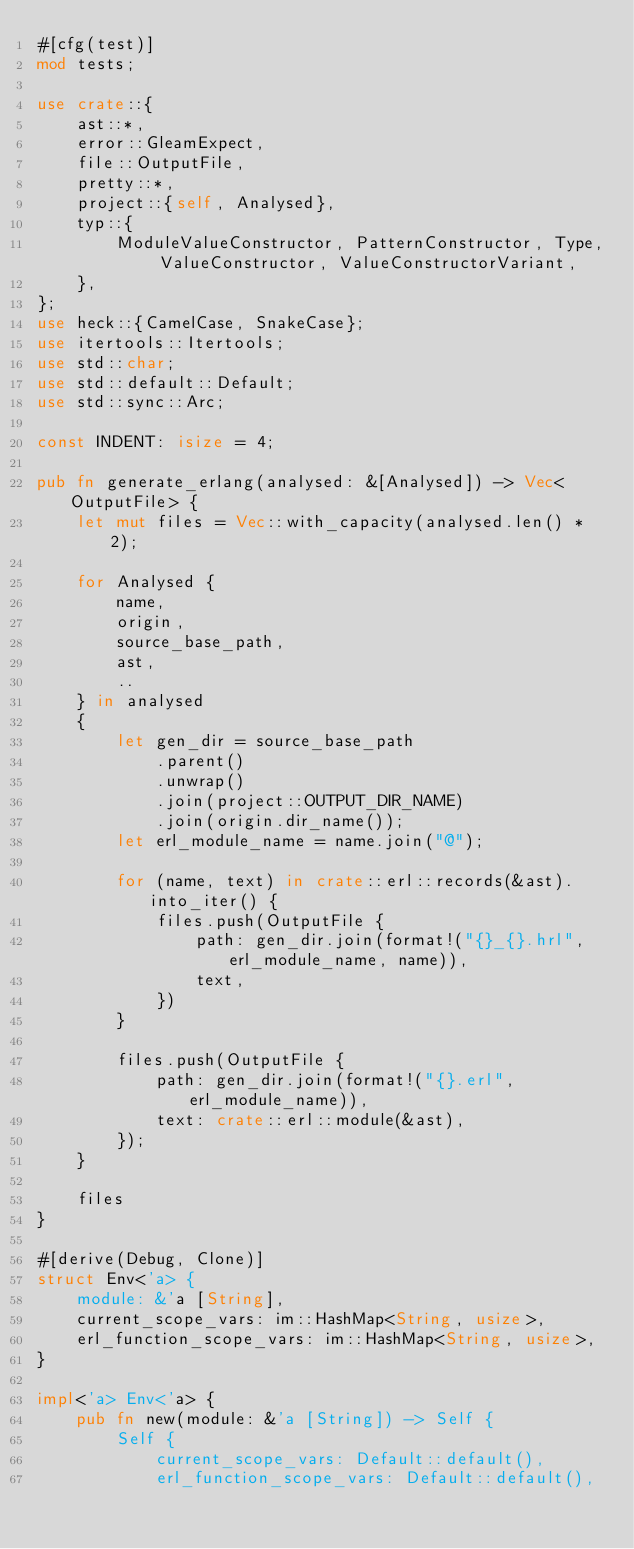Convert code to text. <code><loc_0><loc_0><loc_500><loc_500><_Rust_>#[cfg(test)]
mod tests;

use crate::{
    ast::*,
    error::GleamExpect,
    file::OutputFile,
    pretty::*,
    project::{self, Analysed},
    typ::{
        ModuleValueConstructor, PatternConstructor, Type, ValueConstructor, ValueConstructorVariant,
    },
};
use heck::{CamelCase, SnakeCase};
use itertools::Itertools;
use std::char;
use std::default::Default;
use std::sync::Arc;

const INDENT: isize = 4;

pub fn generate_erlang(analysed: &[Analysed]) -> Vec<OutputFile> {
    let mut files = Vec::with_capacity(analysed.len() * 2);

    for Analysed {
        name,
        origin,
        source_base_path,
        ast,
        ..
    } in analysed
    {
        let gen_dir = source_base_path
            .parent()
            .unwrap()
            .join(project::OUTPUT_DIR_NAME)
            .join(origin.dir_name());
        let erl_module_name = name.join("@");

        for (name, text) in crate::erl::records(&ast).into_iter() {
            files.push(OutputFile {
                path: gen_dir.join(format!("{}_{}.hrl", erl_module_name, name)),
                text,
            })
        }

        files.push(OutputFile {
            path: gen_dir.join(format!("{}.erl", erl_module_name)),
            text: crate::erl::module(&ast),
        });
    }

    files
}

#[derive(Debug, Clone)]
struct Env<'a> {
    module: &'a [String],
    current_scope_vars: im::HashMap<String, usize>,
    erl_function_scope_vars: im::HashMap<String, usize>,
}

impl<'a> Env<'a> {
    pub fn new(module: &'a [String]) -> Self {
        Self {
            current_scope_vars: Default::default(),
            erl_function_scope_vars: Default::default(),</code> 